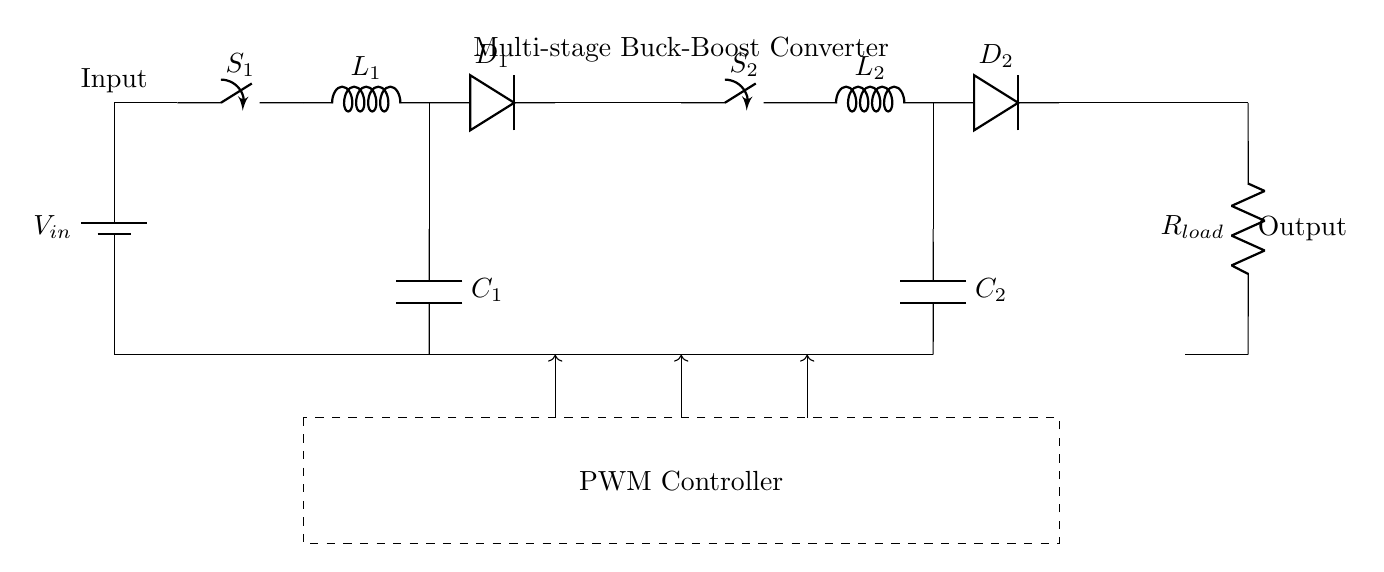What is the type of converter shown in the diagram? The diagram depicts a multi-stage buck-boost converter, which is characterized by its ability to step down (buck) and step up (boost) voltage levels. This is confirmed by the presence of switches, inductors, and diodes arranged in two stages.
Answer: Multi-stage buck-boost converter How many inductors are used in this circuit? The circuit contains two inductors, labeled as L1 and L2, which are integral parts of the buck-boost conversion process. They are placed in each of the two stages of the converter.
Answer: 2 What is the role of the PWM controller in this circuit? The PWM controller regulates the switching of S1 and S2, controlling the duty cycle to adjust the output voltage accordingly. It is vital for maintaining stable output regardless of input voltage variations.
Answer: Regulation What is the load resistance in the output section? The load resistance is represented by R_load, which is connected to the output terminals of the circuit. While a specific value is not stated in this diagram, it is critical for determining the output current and power.
Answer: R_load What happens to the output voltage if both switches are closed simultaneously? If both switches are closed at the same time, the circuit operates in a mode where energy is drawn from both stages, potentially increasing the output voltage significantly due to simultaneous contributions from both inductors.
Answer: Increases Which components are used for energy storage in the circuit? The components used for energy storage are the inductors L1 and L2 and the capacitors C1 and C2. Inductors store energy in a magnetic field, while capacitors store energy in an electric field, critical for the buck-boost function.
Answer: Inductors and capacitors What is the function of the diode in each stage? The diodes D1 and D2 allow current to flow in only one direction, preventing reverse flow that could disrupt the voltage regulation process in the converter stages. They ensure that energy is transferred to the load correctly without feedback interference.
Answer: Current direction 